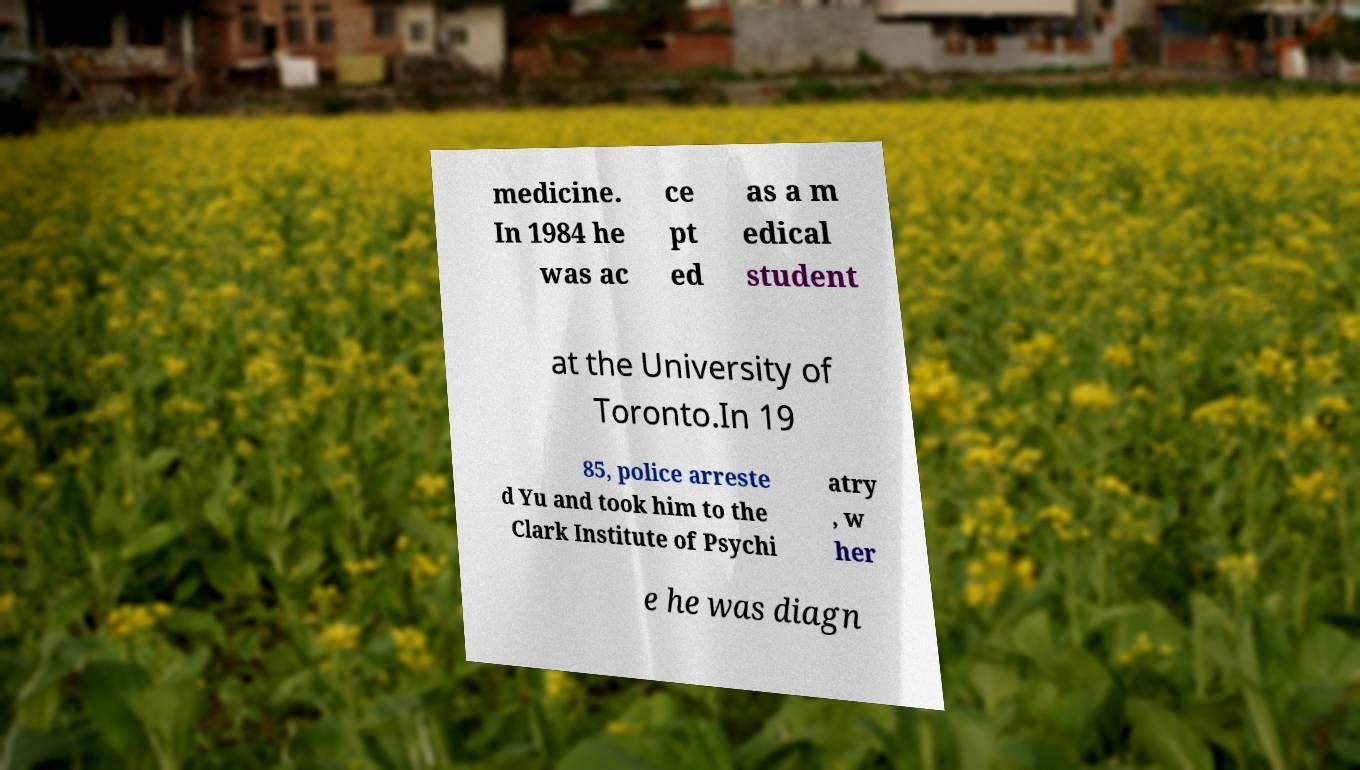Please read and relay the text visible in this image. What does it say? medicine. In 1984 he was ac ce pt ed as a m edical student at the University of Toronto.In 19 85, police arreste d Yu and took him to the Clark Institute of Psychi atry , w her e he was diagn 